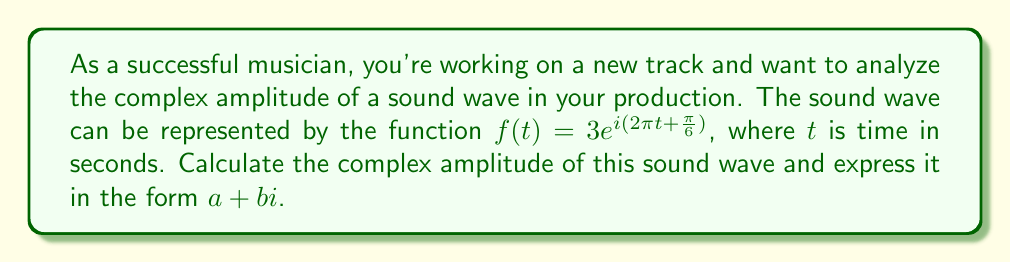Help me with this question. To solve this problem, let's break it down into steps:

1) The general form of a complex wave function is:

   $$f(t) = Ae^{i(\omega t + \phi)}$$

   where $A$ is the amplitude, $\omega$ is the angular frequency, and $\phi$ is the phase angle.

2) Comparing our given function to this general form:

   $$f(t) = 3e^{i(2\pi t + \frac{\pi}{6})}$$

   We can see that $A = 3$, $\omega = 2\pi$, and $\phi = \frac{\pi}{6}$.

3) The complex amplitude is the complex number that represents both the magnitude and the initial phase of the wave. It's given by:

   $$Ae^{i\phi}$$

4) Substituting our values:

   $$3e^{i\frac{\pi}{6}}$$

5) To express this in the form $a + bi$, we need to use Euler's formula:

   $$e^{i\theta} = \cos\theta + i\sin\theta$$

6) Applying this to our expression:

   $$3e^{i\frac{\pi}{6}} = 3(\cos\frac{\pi}{6} + i\sin\frac{\pi}{6})$$

7) We know that:
   
   $$\cos\frac{\pi}{6} = \frac{\sqrt{3}}{2}$$
   $$\sin\frac{\pi}{6} = \frac{1}{2}$$

8) Substituting these values:

   $$3e^{i\frac{\pi}{6}} = 3(\frac{\sqrt{3}}{2} + i\frac{1}{2})$$

9) Simplifying:

   $$3e^{i\frac{\pi}{6}} = \frac{3\sqrt{3}}{2} + i\frac{3}{2}$$

This is our complex amplitude in the form $a + bi$.
Answer: The complex amplitude is $\frac{3\sqrt{3}}{2} + i\frac{3}{2}$. 